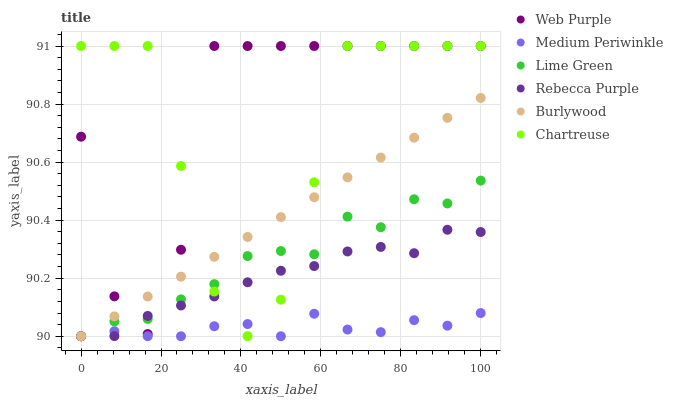Does Medium Periwinkle have the minimum area under the curve?
Answer yes or no. Yes. Does Web Purple have the maximum area under the curve?
Answer yes or no. Yes. Does Chartreuse have the minimum area under the curve?
Answer yes or no. No. Does Chartreuse have the maximum area under the curve?
Answer yes or no. No. Is Burlywood the smoothest?
Answer yes or no. Yes. Is Web Purple the roughest?
Answer yes or no. Yes. Is Medium Periwinkle the smoothest?
Answer yes or no. No. Is Medium Periwinkle the roughest?
Answer yes or no. No. Does Burlywood have the lowest value?
Answer yes or no. Yes. Does Chartreuse have the lowest value?
Answer yes or no. No. Does Web Purple have the highest value?
Answer yes or no. Yes. Does Medium Periwinkle have the highest value?
Answer yes or no. No. Is Medium Periwinkle less than Web Purple?
Answer yes or no. Yes. Is Web Purple greater than Medium Periwinkle?
Answer yes or no. Yes. Does Rebecca Purple intersect Burlywood?
Answer yes or no. Yes. Is Rebecca Purple less than Burlywood?
Answer yes or no. No. Is Rebecca Purple greater than Burlywood?
Answer yes or no. No. Does Medium Periwinkle intersect Web Purple?
Answer yes or no. No. 